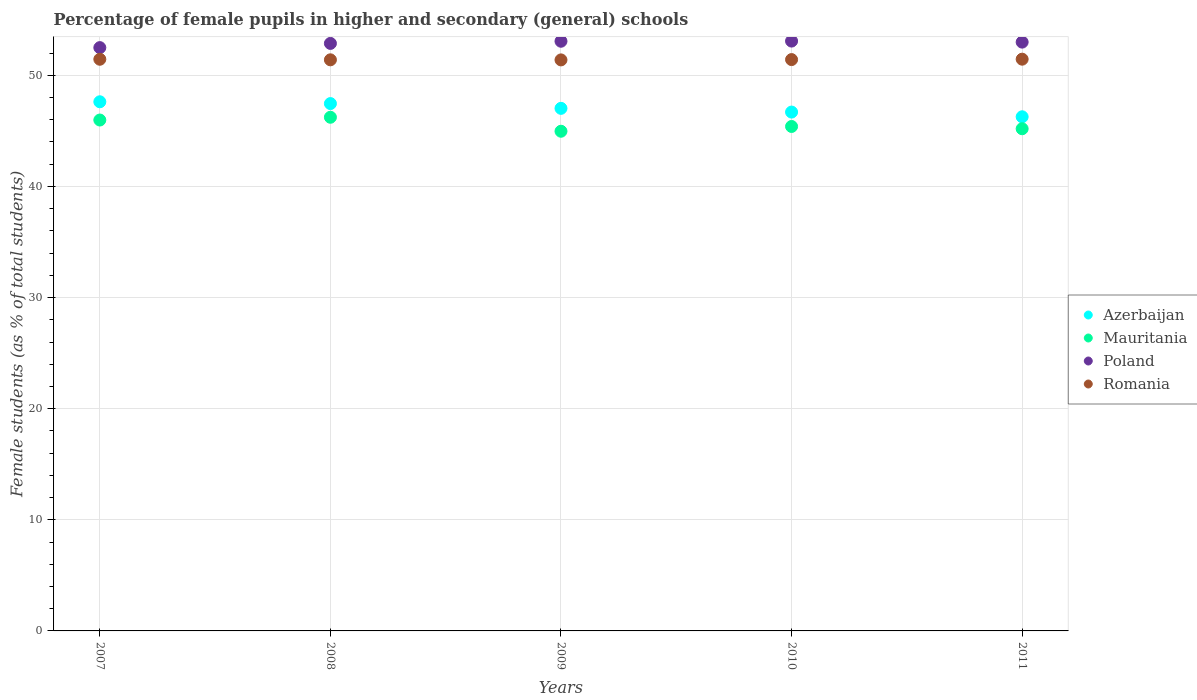Is the number of dotlines equal to the number of legend labels?
Provide a succinct answer. Yes. What is the percentage of female pupils in higher and secondary schools in Romania in 2010?
Provide a short and direct response. 51.42. Across all years, what is the maximum percentage of female pupils in higher and secondary schools in Azerbaijan?
Offer a terse response. 47.62. Across all years, what is the minimum percentage of female pupils in higher and secondary schools in Romania?
Your response must be concise. 51.39. In which year was the percentage of female pupils in higher and secondary schools in Poland maximum?
Your answer should be compact. 2010. In which year was the percentage of female pupils in higher and secondary schools in Mauritania minimum?
Your response must be concise. 2009. What is the total percentage of female pupils in higher and secondary schools in Romania in the graph?
Give a very brief answer. 257.1. What is the difference between the percentage of female pupils in higher and secondary schools in Mauritania in 2007 and that in 2008?
Offer a terse response. -0.25. What is the difference between the percentage of female pupils in higher and secondary schools in Azerbaijan in 2007 and the percentage of female pupils in higher and secondary schools in Romania in 2009?
Give a very brief answer. -3.77. What is the average percentage of female pupils in higher and secondary schools in Mauritania per year?
Keep it short and to the point. 45.55. In the year 2007, what is the difference between the percentage of female pupils in higher and secondary schools in Azerbaijan and percentage of female pupils in higher and secondary schools in Poland?
Your answer should be compact. -4.87. In how many years, is the percentage of female pupils in higher and secondary schools in Azerbaijan greater than 36 %?
Give a very brief answer. 5. What is the ratio of the percentage of female pupils in higher and secondary schools in Azerbaijan in 2008 to that in 2009?
Your answer should be very brief. 1.01. What is the difference between the highest and the second highest percentage of female pupils in higher and secondary schools in Mauritania?
Your answer should be compact. 0.25. What is the difference between the highest and the lowest percentage of female pupils in higher and secondary schools in Mauritania?
Make the answer very short. 1.26. Is the sum of the percentage of female pupils in higher and secondary schools in Romania in 2009 and 2011 greater than the maximum percentage of female pupils in higher and secondary schools in Poland across all years?
Keep it short and to the point. Yes. Is the percentage of female pupils in higher and secondary schools in Mauritania strictly less than the percentage of female pupils in higher and secondary schools in Azerbaijan over the years?
Your response must be concise. Yes. How many dotlines are there?
Your response must be concise. 4. How many years are there in the graph?
Your answer should be compact. 5. What is the difference between two consecutive major ticks on the Y-axis?
Your answer should be compact. 10. Where does the legend appear in the graph?
Provide a succinct answer. Center right. How many legend labels are there?
Ensure brevity in your answer.  4. How are the legend labels stacked?
Offer a terse response. Vertical. What is the title of the graph?
Provide a succinct answer. Percentage of female pupils in higher and secondary (general) schools. Does "Cuba" appear as one of the legend labels in the graph?
Your answer should be very brief. No. What is the label or title of the Y-axis?
Ensure brevity in your answer.  Female students (as % of total students). What is the Female students (as % of total students) in Azerbaijan in 2007?
Offer a very short reply. 47.62. What is the Female students (as % of total students) in Mauritania in 2007?
Provide a succinct answer. 45.98. What is the Female students (as % of total students) of Poland in 2007?
Ensure brevity in your answer.  52.49. What is the Female students (as % of total students) in Romania in 2007?
Ensure brevity in your answer.  51.45. What is the Female students (as % of total students) in Azerbaijan in 2008?
Your answer should be compact. 47.46. What is the Female students (as % of total students) of Mauritania in 2008?
Give a very brief answer. 46.23. What is the Female students (as % of total students) in Poland in 2008?
Your answer should be compact. 52.87. What is the Female students (as % of total students) of Romania in 2008?
Your answer should be compact. 51.4. What is the Female students (as % of total students) in Azerbaijan in 2009?
Give a very brief answer. 47.03. What is the Female students (as % of total students) of Mauritania in 2009?
Give a very brief answer. 44.97. What is the Female students (as % of total students) in Poland in 2009?
Provide a succinct answer. 53.07. What is the Female students (as % of total students) in Romania in 2009?
Provide a succinct answer. 51.39. What is the Female students (as % of total students) in Azerbaijan in 2010?
Your response must be concise. 46.69. What is the Female students (as % of total students) in Mauritania in 2010?
Provide a succinct answer. 45.4. What is the Female students (as % of total students) of Poland in 2010?
Make the answer very short. 53.08. What is the Female students (as % of total students) of Romania in 2010?
Offer a very short reply. 51.42. What is the Female students (as % of total students) of Azerbaijan in 2011?
Your answer should be very brief. 46.27. What is the Female students (as % of total students) in Mauritania in 2011?
Give a very brief answer. 45.19. What is the Female students (as % of total students) of Poland in 2011?
Ensure brevity in your answer.  52.99. What is the Female students (as % of total students) of Romania in 2011?
Give a very brief answer. 51.45. Across all years, what is the maximum Female students (as % of total students) of Azerbaijan?
Your response must be concise. 47.62. Across all years, what is the maximum Female students (as % of total students) in Mauritania?
Offer a terse response. 46.23. Across all years, what is the maximum Female students (as % of total students) of Poland?
Keep it short and to the point. 53.08. Across all years, what is the maximum Female students (as % of total students) in Romania?
Your response must be concise. 51.45. Across all years, what is the minimum Female students (as % of total students) in Azerbaijan?
Give a very brief answer. 46.27. Across all years, what is the minimum Female students (as % of total students) of Mauritania?
Ensure brevity in your answer.  44.97. Across all years, what is the minimum Female students (as % of total students) in Poland?
Offer a terse response. 52.49. Across all years, what is the minimum Female students (as % of total students) of Romania?
Ensure brevity in your answer.  51.39. What is the total Female students (as % of total students) in Azerbaijan in the graph?
Your answer should be compact. 235.07. What is the total Female students (as % of total students) in Mauritania in the graph?
Your answer should be very brief. 227.76. What is the total Female students (as % of total students) of Poland in the graph?
Your answer should be compact. 264.5. What is the total Female students (as % of total students) of Romania in the graph?
Provide a succinct answer. 257.1. What is the difference between the Female students (as % of total students) of Azerbaijan in 2007 and that in 2008?
Your response must be concise. 0.16. What is the difference between the Female students (as % of total students) in Mauritania in 2007 and that in 2008?
Offer a very short reply. -0.25. What is the difference between the Female students (as % of total students) of Poland in 2007 and that in 2008?
Provide a short and direct response. -0.38. What is the difference between the Female students (as % of total students) in Romania in 2007 and that in 2008?
Provide a succinct answer. 0.05. What is the difference between the Female students (as % of total students) in Azerbaijan in 2007 and that in 2009?
Provide a succinct answer. 0.59. What is the difference between the Female students (as % of total students) in Mauritania in 2007 and that in 2009?
Ensure brevity in your answer.  1.01. What is the difference between the Female students (as % of total students) in Poland in 2007 and that in 2009?
Provide a succinct answer. -0.57. What is the difference between the Female students (as % of total students) of Romania in 2007 and that in 2009?
Give a very brief answer. 0.06. What is the difference between the Female students (as % of total students) in Azerbaijan in 2007 and that in 2010?
Offer a very short reply. 0.93. What is the difference between the Female students (as % of total students) of Mauritania in 2007 and that in 2010?
Provide a succinct answer. 0.58. What is the difference between the Female students (as % of total students) of Poland in 2007 and that in 2010?
Offer a terse response. -0.59. What is the difference between the Female students (as % of total students) in Romania in 2007 and that in 2010?
Offer a terse response. 0.03. What is the difference between the Female students (as % of total students) in Azerbaijan in 2007 and that in 2011?
Offer a very short reply. 1.35. What is the difference between the Female students (as % of total students) in Mauritania in 2007 and that in 2011?
Give a very brief answer. 0.78. What is the difference between the Female students (as % of total students) of Poland in 2007 and that in 2011?
Ensure brevity in your answer.  -0.49. What is the difference between the Female students (as % of total students) of Romania in 2007 and that in 2011?
Offer a very short reply. -0.01. What is the difference between the Female students (as % of total students) of Azerbaijan in 2008 and that in 2009?
Your answer should be very brief. 0.43. What is the difference between the Female students (as % of total students) in Mauritania in 2008 and that in 2009?
Make the answer very short. 1.26. What is the difference between the Female students (as % of total students) in Poland in 2008 and that in 2009?
Keep it short and to the point. -0.19. What is the difference between the Female students (as % of total students) of Romania in 2008 and that in 2009?
Provide a short and direct response. 0.01. What is the difference between the Female students (as % of total students) of Azerbaijan in 2008 and that in 2010?
Your answer should be very brief. 0.76. What is the difference between the Female students (as % of total students) of Mauritania in 2008 and that in 2010?
Ensure brevity in your answer.  0.83. What is the difference between the Female students (as % of total students) in Poland in 2008 and that in 2010?
Provide a short and direct response. -0.21. What is the difference between the Female students (as % of total students) of Romania in 2008 and that in 2010?
Make the answer very short. -0.02. What is the difference between the Female students (as % of total students) of Azerbaijan in 2008 and that in 2011?
Your answer should be compact. 1.19. What is the difference between the Female students (as % of total students) of Mauritania in 2008 and that in 2011?
Offer a very short reply. 1.03. What is the difference between the Female students (as % of total students) of Poland in 2008 and that in 2011?
Provide a short and direct response. -0.12. What is the difference between the Female students (as % of total students) of Romania in 2008 and that in 2011?
Keep it short and to the point. -0.06. What is the difference between the Female students (as % of total students) in Azerbaijan in 2009 and that in 2010?
Your answer should be very brief. 0.34. What is the difference between the Female students (as % of total students) of Mauritania in 2009 and that in 2010?
Your answer should be very brief. -0.43. What is the difference between the Female students (as % of total students) of Poland in 2009 and that in 2010?
Offer a very short reply. -0.01. What is the difference between the Female students (as % of total students) in Romania in 2009 and that in 2010?
Your answer should be very brief. -0.03. What is the difference between the Female students (as % of total students) of Azerbaijan in 2009 and that in 2011?
Provide a succinct answer. 0.76. What is the difference between the Female students (as % of total students) in Mauritania in 2009 and that in 2011?
Your answer should be very brief. -0.22. What is the difference between the Female students (as % of total students) in Poland in 2009 and that in 2011?
Make the answer very short. 0.08. What is the difference between the Female students (as % of total students) of Romania in 2009 and that in 2011?
Provide a succinct answer. -0.06. What is the difference between the Female students (as % of total students) in Azerbaijan in 2010 and that in 2011?
Provide a succinct answer. 0.42. What is the difference between the Female students (as % of total students) of Mauritania in 2010 and that in 2011?
Make the answer very short. 0.2. What is the difference between the Female students (as % of total students) of Poland in 2010 and that in 2011?
Your answer should be very brief. 0.09. What is the difference between the Female students (as % of total students) of Romania in 2010 and that in 2011?
Offer a very short reply. -0.04. What is the difference between the Female students (as % of total students) of Azerbaijan in 2007 and the Female students (as % of total students) of Mauritania in 2008?
Ensure brevity in your answer.  1.39. What is the difference between the Female students (as % of total students) in Azerbaijan in 2007 and the Female students (as % of total students) in Poland in 2008?
Provide a short and direct response. -5.25. What is the difference between the Female students (as % of total students) in Azerbaijan in 2007 and the Female students (as % of total students) in Romania in 2008?
Provide a short and direct response. -3.78. What is the difference between the Female students (as % of total students) in Mauritania in 2007 and the Female students (as % of total students) in Poland in 2008?
Your answer should be compact. -6.89. What is the difference between the Female students (as % of total students) of Mauritania in 2007 and the Female students (as % of total students) of Romania in 2008?
Provide a succinct answer. -5.42. What is the difference between the Female students (as % of total students) in Poland in 2007 and the Female students (as % of total students) in Romania in 2008?
Offer a very short reply. 1.1. What is the difference between the Female students (as % of total students) in Azerbaijan in 2007 and the Female students (as % of total students) in Mauritania in 2009?
Keep it short and to the point. 2.65. What is the difference between the Female students (as % of total students) in Azerbaijan in 2007 and the Female students (as % of total students) in Poland in 2009?
Your answer should be very brief. -5.45. What is the difference between the Female students (as % of total students) of Azerbaijan in 2007 and the Female students (as % of total students) of Romania in 2009?
Keep it short and to the point. -3.77. What is the difference between the Female students (as % of total students) in Mauritania in 2007 and the Female students (as % of total students) in Poland in 2009?
Ensure brevity in your answer.  -7.09. What is the difference between the Female students (as % of total students) of Mauritania in 2007 and the Female students (as % of total students) of Romania in 2009?
Your response must be concise. -5.41. What is the difference between the Female students (as % of total students) in Poland in 2007 and the Female students (as % of total students) in Romania in 2009?
Your response must be concise. 1.11. What is the difference between the Female students (as % of total students) in Azerbaijan in 2007 and the Female students (as % of total students) in Mauritania in 2010?
Offer a very short reply. 2.22. What is the difference between the Female students (as % of total students) of Azerbaijan in 2007 and the Female students (as % of total students) of Poland in 2010?
Offer a very short reply. -5.46. What is the difference between the Female students (as % of total students) of Azerbaijan in 2007 and the Female students (as % of total students) of Romania in 2010?
Make the answer very short. -3.8. What is the difference between the Female students (as % of total students) of Mauritania in 2007 and the Female students (as % of total students) of Poland in 2010?
Provide a short and direct response. -7.1. What is the difference between the Female students (as % of total students) in Mauritania in 2007 and the Female students (as % of total students) in Romania in 2010?
Keep it short and to the point. -5.44. What is the difference between the Female students (as % of total students) of Poland in 2007 and the Female students (as % of total students) of Romania in 2010?
Keep it short and to the point. 1.08. What is the difference between the Female students (as % of total students) of Azerbaijan in 2007 and the Female students (as % of total students) of Mauritania in 2011?
Your response must be concise. 2.43. What is the difference between the Female students (as % of total students) of Azerbaijan in 2007 and the Female students (as % of total students) of Poland in 2011?
Keep it short and to the point. -5.37. What is the difference between the Female students (as % of total students) in Azerbaijan in 2007 and the Female students (as % of total students) in Romania in 2011?
Your answer should be compact. -3.83. What is the difference between the Female students (as % of total students) in Mauritania in 2007 and the Female students (as % of total students) in Poland in 2011?
Offer a very short reply. -7.01. What is the difference between the Female students (as % of total students) in Mauritania in 2007 and the Female students (as % of total students) in Romania in 2011?
Offer a very short reply. -5.48. What is the difference between the Female students (as % of total students) of Poland in 2007 and the Female students (as % of total students) of Romania in 2011?
Give a very brief answer. 1.04. What is the difference between the Female students (as % of total students) of Azerbaijan in 2008 and the Female students (as % of total students) of Mauritania in 2009?
Your response must be concise. 2.49. What is the difference between the Female students (as % of total students) of Azerbaijan in 2008 and the Female students (as % of total students) of Poland in 2009?
Your answer should be very brief. -5.61. What is the difference between the Female students (as % of total students) in Azerbaijan in 2008 and the Female students (as % of total students) in Romania in 2009?
Offer a terse response. -3.93. What is the difference between the Female students (as % of total students) of Mauritania in 2008 and the Female students (as % of total students) of Poland in 2009?
Your answer should be compact. -6.84. What is the difference between the Female students (as % of total students) in Mauritania in 2008 and the Female students (as % of total students) in Romania in 2009?
Ensure brevity in your answer.  -5.16. What is the difference between the Female students (as % of total students) in Poland in 2008 and the Female students (as % of total students) in Romania in 2009?
Offer a very short reply. 1.48. What is the difference between the Female students (as % of total students) of Azerbaijan in 2008 and the Female students (as % of total students) of Mauritania in 2010?
Keep it short and to the point. 2.06. What is the difference between the Female students (as % of total students) of Azerbaijan in 2008 and the Female students (as % of total students) of Poland in 2010?
Your response must be concise. -5.62. What is the difference between the Female students (as % of total students) of Azerbaijan in 2008 and the Female students (as % of total students) of Romania in 2010?
Your answer should be compact. -3.96. What is the difference between the Female students (as % of total students) in Mauritania in 2008 and the Female students (as % of total students) in Poland in 2010?
Offer a terse response. -6.86. What is the difference between the Female students (as % of total students) in Mauritania in 2008 and the Female students (as % of total students) in Romania in 2010?
Your answer should be very brief. -5.19. What is the difference between the Female students (as % of total students) in Poland in 2008 and the Female students (as % of total students) in Romania in 2010?
Keep it short and to the point. 1.46. What is the difference between the Female students (as % of total students) in Azerbaijan in 2008 and the Female students (as % of total students) in Mauritania in 2011?
Your answer should be very brief. 2.26. What is the difference between the Female students (as % of total students) in Azerbaijan in 2008 and the Female students (as % of total students) in Poland in 2011?
Provide a short and direct response. -5.53. What is the difference between the Female students (as % of total students) in Azerbaijan in 2008 and the Female students (as % of total students) in Romania in 2011?
Your answer should be compact. -4. What is the difference between the Female students (as % of total students) of Mauritania in 2008 and the Female students (as % of total students) of Poland in 2011?
Your answer should be compact. -6.76. What is the difference between the Female students (as % of total students) of Mauritania in 2008 and the Female students (as % of total students) of Romania in 2011?
Keep it short and to the point. -5.23. What is the difference between the Female students (as % of total students) of Poland in 2008 and the Female students (as % of total students) of Romania in 2011?
Offer a terse response. 1.42. What is the difference between the Female students (as % of total students) in Azerbaijan in 2009 and the Female students (as % of total students) in Mauritania in 2010?
Your response must be concise. 1.63. What is the difference between the Female students (as % of total students) of Azerbaijan in 2009 and the Female students (as % of total students) of Poland in 2010?
Offer a very short reply. -6.05. What is the difference between the Female students (as % of total students) in Azerbaijan in 2009 and the Female students (as % of total students) in Romania in 2010?
Offer a terse response. -4.39. What is the difference between the Female students (as % of total students) of Mauritania in 2009 and the Female students (as % of total students) of Poland in 2010?
Ensure brevity in your answer.  -8.11. What is the difference between the Female students (as % of total students) in Mauritania in 2009 and the Female students (as % of total students) in Romania in 2010?
Give a very brief answer. -6.45. What is the difference between the Female students (as % of total students) in Poland in 2009 and the Female students (as % of total students) in Romania in 2010?
Provide a short and direct response. 1.65. What is the difference between the Female students (as % of total students) of Azerbaijan in 2009 and the Female students (as % of total students) of Mauritania in 2011?
Your response must be concise. 1.84. What is the difference between the Female students (as % of total students) of Azerbaijan in 2009 and the Female students (as % of total students) of Poland in 2011?
Your answer should be compact. -5.96. What is the difference between the Female students (as % of total students) of Azerbaijan in 2009 and the Female students (as % of total students) of Romania in 2011?
Your answer should be very brief. -4.42. What is the difference between the Female students (as % of total students) in Mauritania in 2009 and the Female students (as % of total students) in Poland in 2011?
Provide a short and direct response. -8.02. What is the difference between the Female students (as % of total students) of Mauritania in 2009 and the Female students (as % of total students) of Romania in 2011?
Give a very brief answer. -6.48. What is the difference between the Female students (as % of total students) in Poland in 2009 and the Female students (as % of total students) in Romania in 2011?
Keep it short and to the point. 1.61. What is the difference between the Female students (as % of total students) of Azerbaijan in 2010 and the Female students (as % of total students) of Mauritania in 2011?
Make the answer very short. 1.5. What is the difference between the Female students (as % of total students) of Azerbaijan in 2010 and the Female students (as % of total students) of Poland in 2011?
Give a very brief answer. -6.3. What is the difference between the Female students (as % of total students) in Azerbaijan in 2010 and the Female students (as % of total students) in Romania in 2011?
Your response must be concise. -4.76. What is the difference between the Female students (as % of total students) of Mauritania in 2010 and the Female students (as % of total students) of Poland in 2011?
Your answer should be compact. -7.59. What is the difference between the Female students (as % of total students) of Mauritania in 2010 and the Female students (as % of total students) of Romania in 2011?
Your answer should be very brief. -6.06. What is the difference between the Female students (as % of total students) of Poland in 2010 and the Female students (as % of total students) of Romania in 2011?
Provide a succinct answer. 1.63. What is the average Female students (as % of total students) in Azerbaijan per year?
Make the answer very short. 47.01. What is the average Female students (as % of total students) in Mauritania per year?
Offer a very short reply. 45.55. What is the average Female students (as % of total students) in Poland per year?
Offer a very short reply. 52.9. What is the average Female students (as % of total students) of Romania per year?
Keep it short and to the point. 51.42. In the year 2007, what is the difference between the Female students (as % of total students) in Azerbaijan and Female students (as % of total students) in Mauritania?
Your answer should be very brief. 1.64. In the year 2007, what is the difference between the Female students (as % of total students) of Azerbaijan and Female students (as % of total students) of Poland?
Your answer should be very brief. -4.87. In the year 2007, what is the difference between the Female students (as % of total students) in Azerbaijan and Female students (as % of total students) in Romania?
Keep it short and to the point. -3.83. In the year 2007, what is the difference between the Female students (as % of total students) of Mauritania and Female students (as % of total students) of Poland?
Keep it short and to the point. -6.52. In the year 2007, what is the difference between the Female students (as % of total students) in Mauritania and Female students (as % of total students) in Romania?
Give a very brief answer. -5.47. In the year 2007, what is the difference between the Female students (as % of total students) in Poland and Female students (as % of total students) in Romania?
Ensure brevity in your answer.  1.05. In the year 2008, what is the difference between the Female students (as % of total students) in Azerbaijan and Female students (as % of total students) in Mauritania?
Offer a terse response. 1.23. In the year 2008, what is the difference between the Female students (as % of total students) in Azerbaijan and Female students (as % of total students) in Poland?
Give a very brief answer. -5.41. In the year 2008, what is the difference between the Female students (as % of total students) in Azerbaijan and Female students (as % of total students) in Romania?
Your answer should be compact. -3.94. In the year 2008, what is the difference between the Female students (as % of total students) of Mauritania and Female students (as % of total students) of Poland?
Offer a very short reply. -6.65. In the year 2008, what is the difference between the Female students (as % of total students) of Mauritania and Female students (as % of total students) of Romania?
Give a very brief answer. -5.17. In the year 2008, what is the difference between the Female students (as % of total students) of Poland and Female students (as % of total students) of Romania?
Your response must be concise. 1.48. In the year 2009, what is the difference between the Female students (as % of total students) in Azerbaijan and Female students (as % of total students) in Mauritania?
Offer a very short reply. 2.06. In the year 2009, what is the difference between the Female students (as % of total students) in Azerbaijan and Female students (as % of total students) in Poland?
Offer a terse response. -6.04. In the year 2009, what is the difference between the Female students (as % of total students) of Azerbaijan and Female students (as % of total students) of Romania?
Keep it short and to the point. -4.36. In the year 2009, what is the difference between the Female students (as % of total students) of Mauritania and Female students (as % of total students) of Poland?
Your answer should be very brief. -8.1. In the year 2009, what is the difference between the Female students (as % of total students) of Mauritania and Female students (as % of total students) of Romania?
Ensure brevity in your answer.  -6.42. In the year 2009, what is the difference between the Female students (as % of total students) of Poland and Female students (as % of total students) of Romania?
Your answer should be very brief. 1.68. In the year 2010, what is the difference between the Female students (as % of total students) of Azerbaijan and Female students (as % of total students) of Mauritania?
Provide a short and direct response. 1.3. In the year 2010, what is the difference between the Female students (as % of total students) in Azerbaijan and Female students (as % of total students) in Poland?
Ensure brevity in your answer.  -6.39. In the year 2010, what is the difference between the Female students (as % of total students) in Azerbaijan and Female students (as % of total students) in Romania?
Give a very brief answer. -4.72. In the year 2010, what is the difference between the Female students (as % of total students) of Mauritania and Female students (as % of total students) of Poland?
Offer a terse response. -7.68. In the year 2010, what is the difference between the Female students (as % of total students) of Mauritania and Female students (as % of total students) of Romania?
Keep it short and to the point. -6.02. In the year 2010, what is the difference between the Female students (as % of total students) in Poland and Female students (as % of total students) in Romania?
Offer a terse response. 1.67. In the year 2011, what is the difference between the Female students (as % of total students) in Azerbaijan and Female students (as % of total students) in Mauritania?
Provide a succinct answer. 1.08. In the year 2011, what is the difference between the Female students (as % of total students) of Azerbaijan and Female students (as % of total students) of Poland?
Your response must be concise. -6.72. In the year 2011, what is the difference between the Female students (as % of total students) of Azerbaijan and Female students (as % of total students) of Romania?
Ensure brevity in your answer.  -5.18. In the year 2011, what is the difference between the Female students (as % of total students) in Mauritania and Female students (as % of total students) in Poland?
Your answer should be very brief. -7.8. In the year 2011, what is the difference between the Female students (as % of total students) in Mauritania and Female students (as % of total students) in Romania?
Keep it short and to the point. -6.26. In the year 2011, what is the difference between the Female students (as % of total students) in Poland and Female students (as % of total students) in Romania?
Make the answer very short. 1.53. What is the ratio of the Female students (as % of total students) of Mauritania in 2007 to that in 2008?
Your answer should be very brief. 0.99. What is the ratio of the Female students (as % of total students) in Romania in 2007 to that in 2008?
Offer a terse response. 1. What is the ratio of the Female students (as % of total students) of Azerbaijan in 2007 to that in 2009?
Provide a short and direct response. 1.01. What is the ratio of the Female students (as % of total students) in Mauritania in 2007 to that in 2009?
Your response must be concise. 1.02. What is the ratio of the Female students (as % of total students) in Poland in 2007 to that in 2009?
Make the answer very short. 0.99. What is the ratio of the Female students (as % of total students) of Azerbaijan in 2007 to that in 2010?
Provide a succinct answer. 1.02. What is the ratio of the Female students (as % of total students) of Mauritania in 2007 to that in 2010?
Your response must be concise. 1.01. What is the ratio of the Female students (as % of total students) in Poland in 2007 to that in 2010?
Make the answer very short. 0.99. What is the ratio of the Female students (as % of total students) of Azerbaijan in 2007 to that in 2011?
Ensure brevity in your answer.  1.03. What is the ratio of the Female students (as % of total students) in Mauritania in 2007 to that in 2011?
Ensure brevity in your answer.  1.02. What is the ratio of the Female students (as % of total students) of Romania in 2007 to that in 2011?
Your answer should be very brief. 1. What is the ratio of the Female students (as % of total students) in Azerbaijan in 2008 to that in 2009?
Your answer should be very brief. 1.01. What is the ratio of the Female students (as % of total students) in Mauritania in 2008 to that in 2009?
Your response must be concise. 1.03. What is the ratio of the Female students (as % of total students) in Poland in 2008 to that in 2009?
Provide a short and direct response. 1. What is the ratio of the Female students (as % of total students) in Azerbaijan in 2008 to that in 2010?
Offer a very short reply. 1.02. What is the ratio of the Female students (as % of total students) in Mauritania in 2008 to that in 2010?
Offer a very short reply. 1.02. What is the ratio of the Female students (as % of total students) of Azerbaijan in 2008 to that in 2011?
Your answer should be very brief. 1.03. What is the ratio of the Female students (as % of total students) of Mauritania in 2008 to that in 2011?
Make the answer very short. 1.02. What is the ratio of the Female students (as % of total students) in Romania in 2008 to that in 2011?
Your answer should be very brief. 1. What is the ratio of the Female students (as % of total students) of Poland in 2009 to that in 2010?
Your response must be concise. 1. What is the ratio of the Female students (as % of total students) of Romania in 2009 to that in 2010?
Offer a very short reply. 1. What is the ratio of the Female students (as % of total students) of Azerbaijan in 2009 to that in 2011?
Make the answer very short. 1.02. What is the ratio of the Female students (as % of total students) of Mauritania in 2009 to that in 2011?
Your answer should be very brief. 0.99. What is the ratio of the Female students (as % of total students) in Azerbaijan in 2010 to that in 2011?
Keep it short and to the point. 1.01. What is the ratio of the Female students (as % of total students) of Poland in 2010 to that in 2011?
Offer a terse response. 1. What is the difference between the highest and the second highest Female students (as % of total students) in Azerbaijan?
Offer a terse response. 0.16. What is the difference between the highest and the second highest Female students (as % of total students) of Mauritania?
Your answer should be very brief. 0.25. What is the difference between the highest and the second highest Female students (as % of total students) in Poland?
Your answer should be compact. 0.01. What is the difference between the highest and the second highest Female students (as % of total students) in Romania?
Offer a very short reply. 0.01. What is the difference between the highest and the lowest Female students (as % of total students) of Azerbaijan?
Provide a short and direct response. 1.35. What is the difference between the highest and the lowest Female students (as % of total students) of Mauritania?
Offer a very short reply. 1.26. What is the difference between the highest and the lowest Female students (as % of total students) in Poland?
Your response must be concise. 0.59. What is the difference between the highest and the lowest Female students (as % of total students) of Romania?
Your answer should be compact. 0.06. 